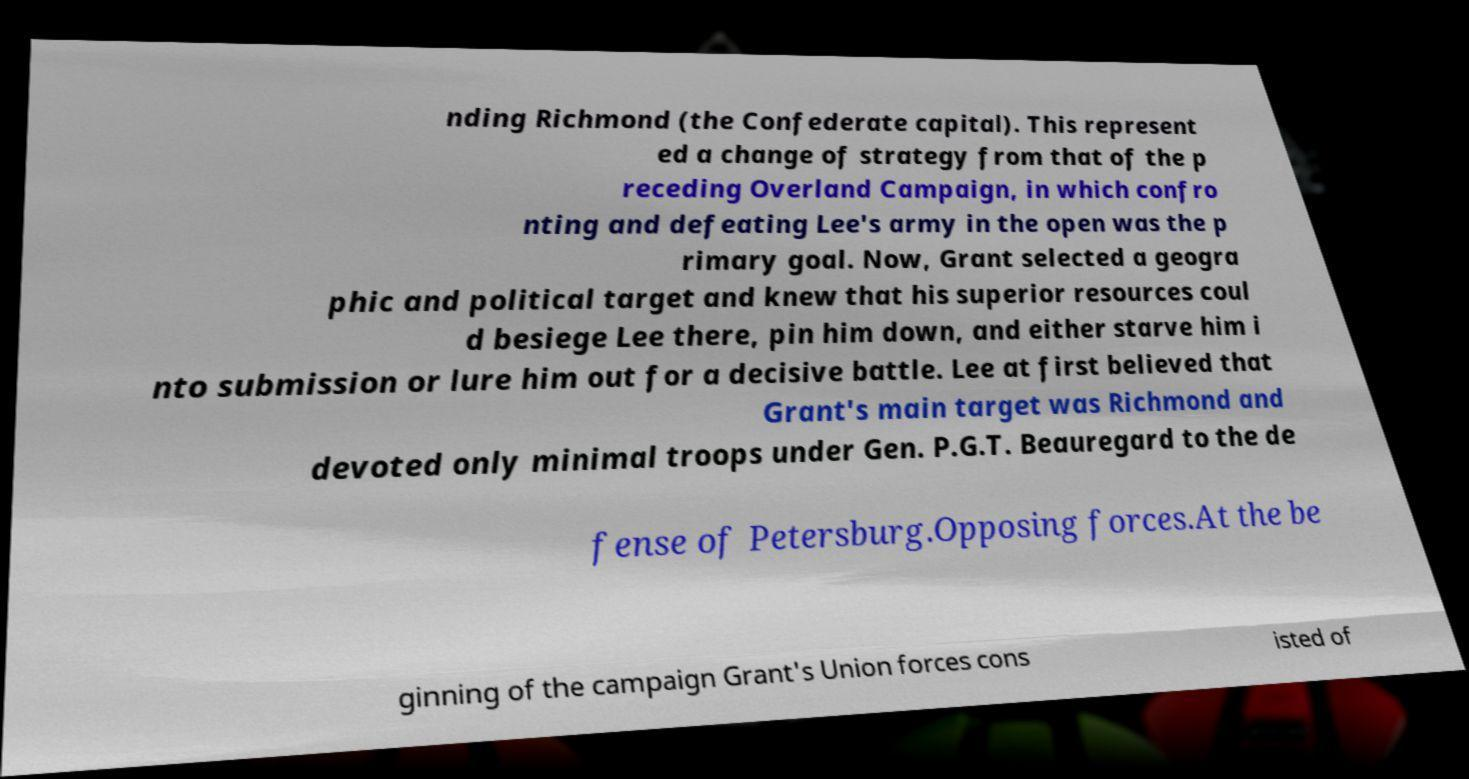Could you assist in decoding the text presented in this image and type it out clearly? nding Richmond (the Confederate capital). This represent ed a change of strategy from that of the p receding Overland Campaign, in which confro nting and defeating Lee's army in the open was the p rimary goal. Now, Grant selected a geogra phic and political target and knew that his superior resources coul d besiege Lee there, pin him down, and either starve him i nto submission or lure him out for a decisive battle. Lee at first believed that Grant's main target was Richmond and devoted only minimal troops under Gen. P.G.T. Beauregard to the de fense of Petersburg.Opposing forces.At the be ginning of the campaign Grant's Union forces cons isted of 